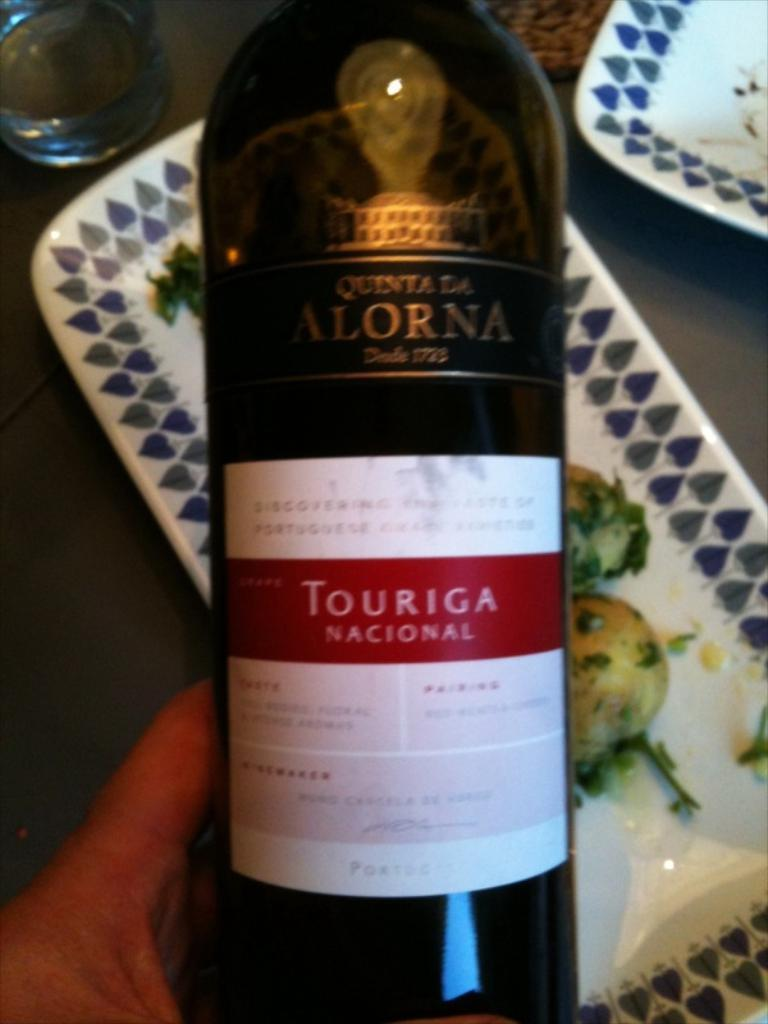<image>
Describe the image concisely. Person holding a bottle with a white label that says "Touriga". 